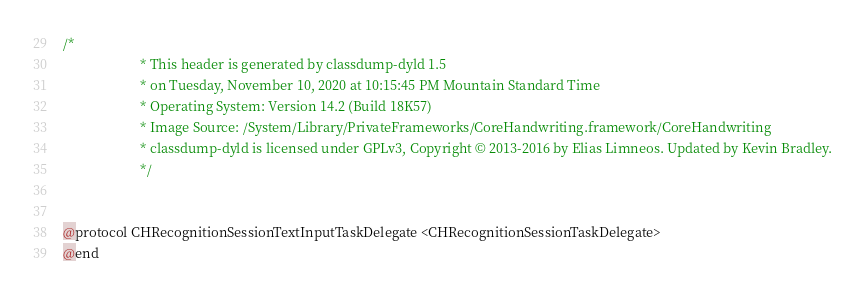<code> <loc_0><loc_0><loc_500><loc_500><_C_>/*
                       * This header is generated by classdump-dyld 1.5
                       * on Tuesday, November 10, 2020 at 10:15:45 PM Mountain Standard Time
                       * Operating System: Version 14.2 (Build 18K57)
                       * Image Source: /System/Library/PrivateFrameworks/CoreHandwriting.framework/CoreHandwriting
                       * classdump-dyld is licensed under GPLv3, Copyright © 2013-2016 by Elias Limneos. Updated by Kevin Bradley.
                       */


@protocol CHRecognitionSessionTextInputTaskDelegate <CHRecognitionSessionTaskDelegate>
@end

</code> 